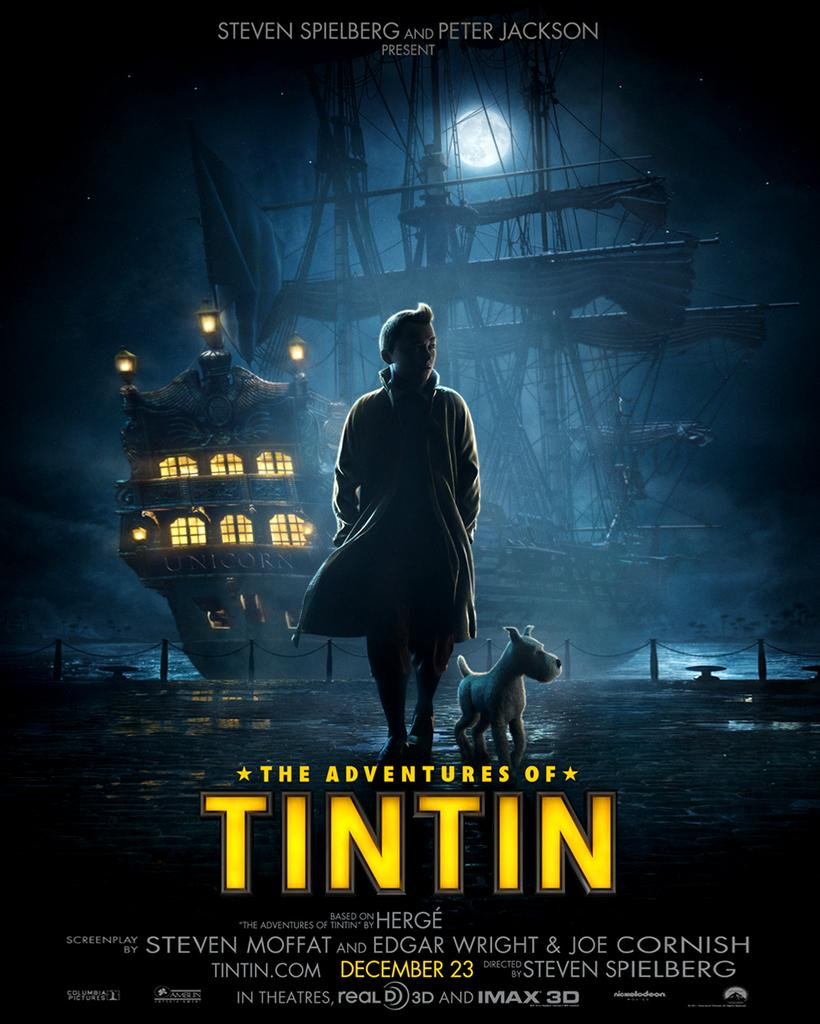<image>
Share a concise interpretation of the image provided. A movie poster beckons moviegoers to enjoy the adventures of young Belgian reporter Tintin. 